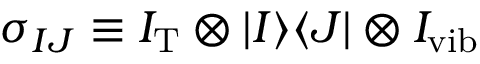<formula> <loc_0><loc_0><loc_500><loc_500>\sigma _ { I J } \equiv I _ { T } \otimes | I \rangle \langle J | \otimes I _ { v i b }</formula> 